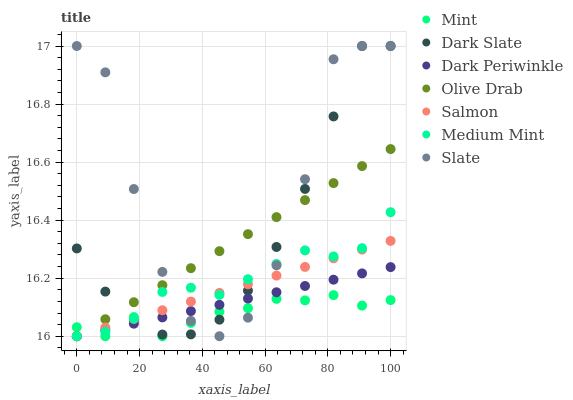Does Mint have the minimum area under the curve?
Answer yes or no. Yes. Does Slate have the maximum area under the curve?
Answer yes or no. Yes. Does Salmon have the minimum area under the curve?
Answer yes or no. No. Does Salmon have the maximum area under the curve?
Answer yes or no. No. Is Olive Drab the smoothest?
Answer yes or no. Yes. Is Slate the roughest?
Answer yes or no. Yes. Is Salmon the smoothest?
Answer yes or no. No. Is Salmon the roughest?
Answer yes or no. No. Does Medium Mint have the lowest value?
Answer yes or no. Yes. Does Slate have the lowest value?
Answer yes or no. No. Does Dark Slate have the highest value?
Answer yes or no. Yes. Does Salmon have the highest value?
Answer yes or no. No. Does Mint intersect Dark Slate?
Answer yes or no. Yes. Is Mint less than Dark Slate?
Answer yes or no. No. Is Mint greater than Dark Slate?
Answer yes or no. No. 